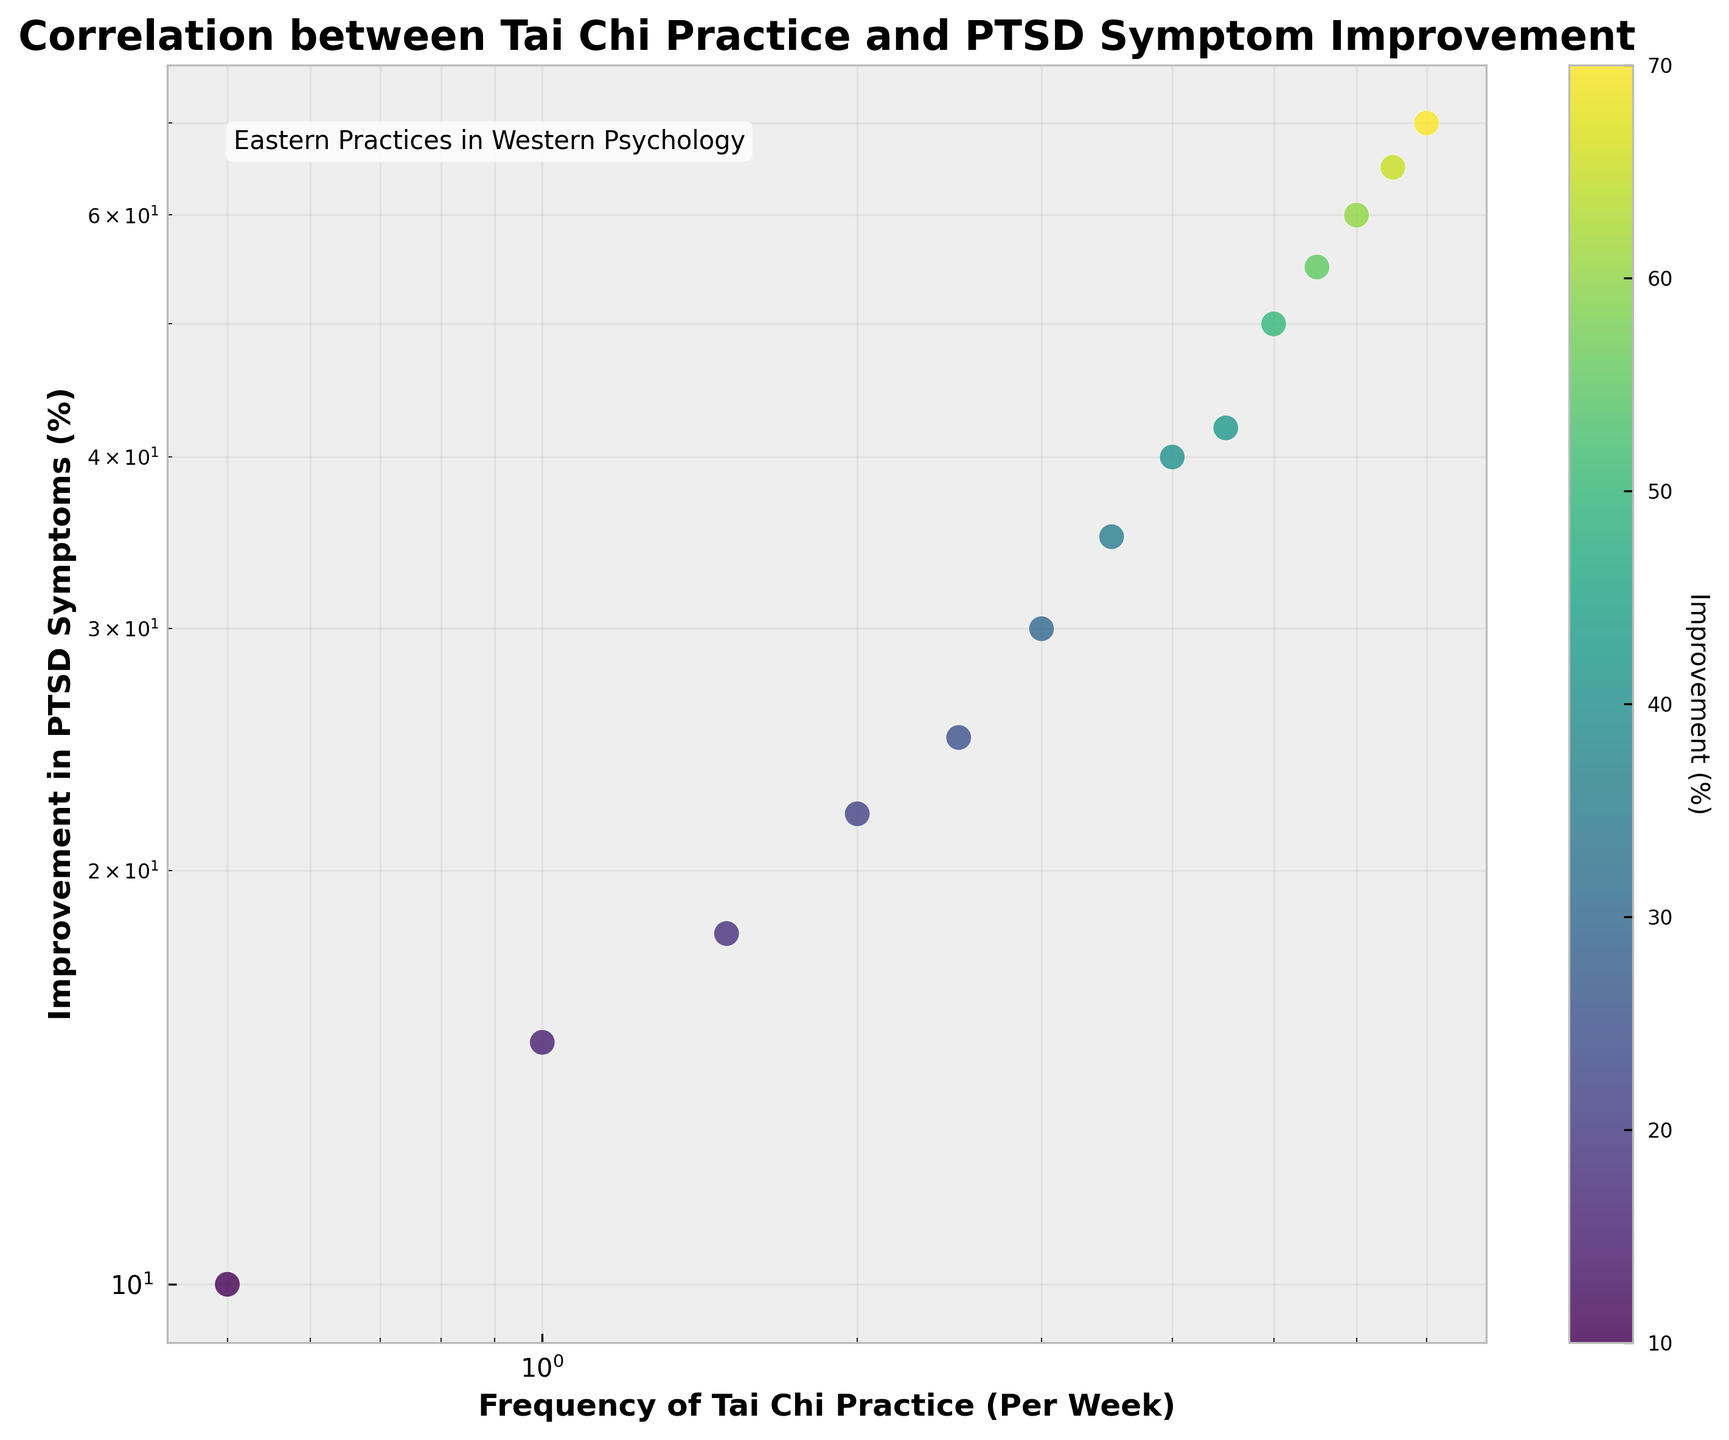What's the title of the plot? The title of any chart is typically positioned prominently at the top of the figure. Here, it reads "Correlation between Tai Chi Practice and PTSD Symptom Improvement"
Answer: Correlation between Tai Chi Practice and PTSD Symptom Improvement What are the labels on the x and y axes? The x-axis label is found along the horizontal axis and the y-axis label along the vertical axis. The x-axis is labeled 'Frequency of Tai Chi Practice (Per Week)' and the y-axis is labeled 'Improvement in PTSD Symptoms (%)'
Answer: Frequency of Tai Chi Practice (Per Week) and Improvement in PTSD Symptoms (%) How many data points are shown in the scatter plot? To determine the number of data points, count each individual point displayed on the scatter plot. There are 14 distinct points representing different practice frequencies and their corresponding improvements.
Answer: 14 Which point shows the highest improvement in PTSD symptoms? By examining the scatter plot, the highest value on the y-axis represents the highest improvement. This highest value, linked to a Tai Chi practice frequency of 7 times per week, shows a 70% improvement.
Answer: 70% How does the colorbar enhance the comprehension of data presented? The colorbar provides a gradient scale indicating improvement percentages, adding a visual layer to interpret the improvement levels of different points. This double encoding (color + position) simplifies recognizing improvements.
Answer: It helps by double encoding improvement percentages, easing the recognition of data points What is the percentage improvement in PTSD symptoms for practicing Tai Chi 3 times per week? Locate the point on the scatter plot corresponding to a frequency of 3 on the x-axis. The y-axis value at this point indicates a 30% improvement.
Answer: 30% If someone practices Tai Chi 4 times per week, what range of PTSD symptom improvement might they expect? Check the point on the scatter plot where the x value is 4. The corresponding y value at this point is 40%, indicating that the expected improvement is about 40%.
Answer: 40% Compare the improvements for practicing Tai Chi 1.5 times and 5 times per week. By identifying both points on the scatter plot, at 1.5 and 5 frequencies per week, we observe improvements at 18% and 50% respectively.
Answer: 18% vs. 50% Does the relationship appear to be linear, exponential, or logarithmic based on the scatter plot with log scale axes? With both axes on a log scale, if the relationship forms a straight line, it suggests a power-law or exponential relationship rather than a linear one. The plotted points form a straight line, indicating an exponential or power-law relationship.
Answer: Exponential What visual cue indicates the prominence of Eastern practices in Western psychology within the plot? The textual annotation included in the upper left of the plot that reads "Eastern Practices in Western Psychology" is a clear visual highlight denoting the integration theme.
Answer: The textual annotation in the top left 